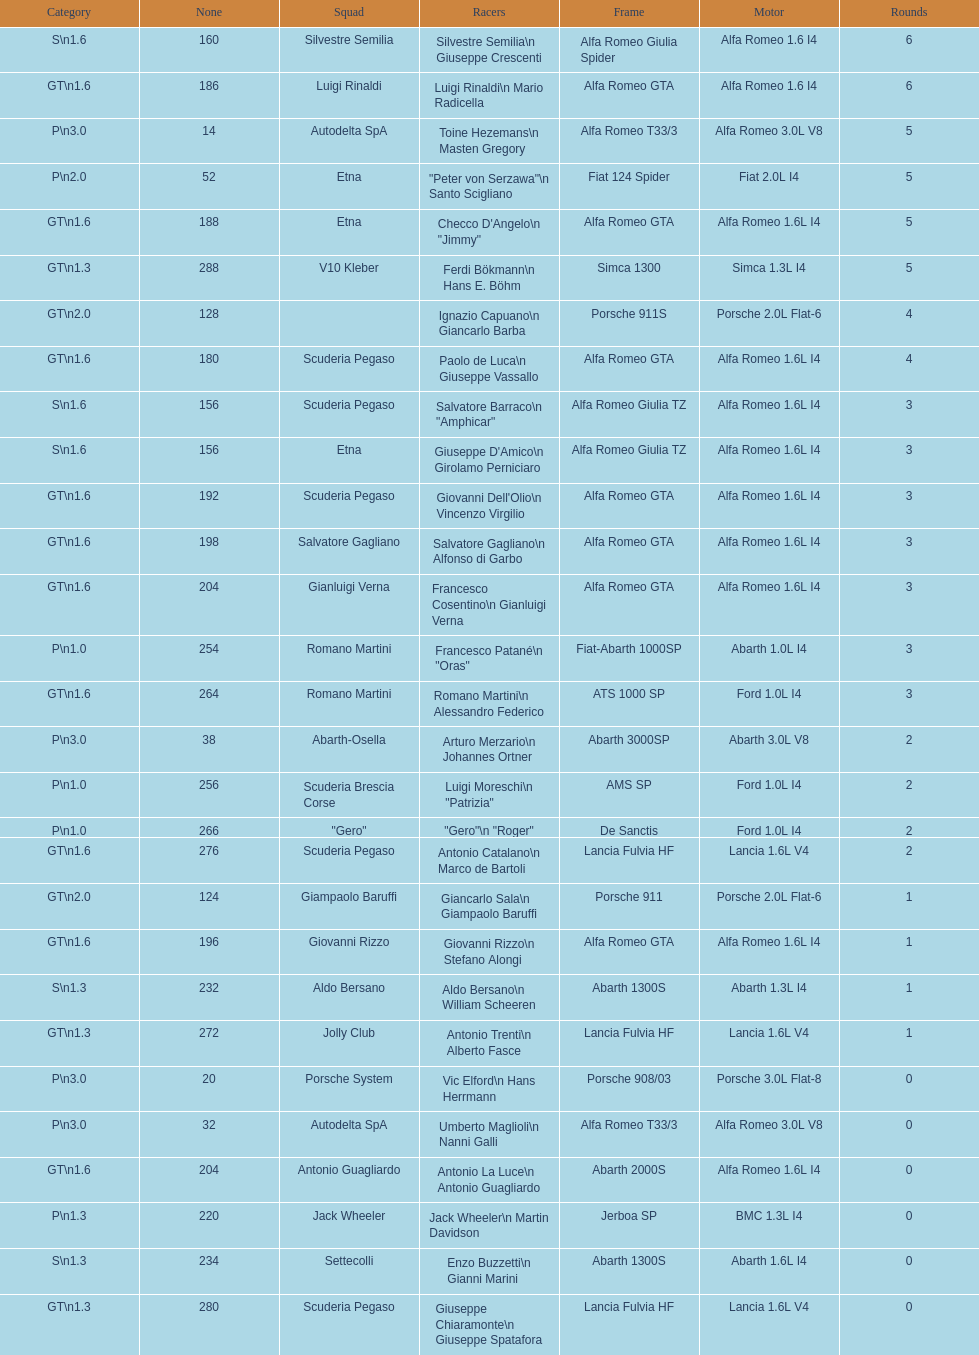Which frame is between simca 1300 and alfa romeo gta? Porsche 911S. 